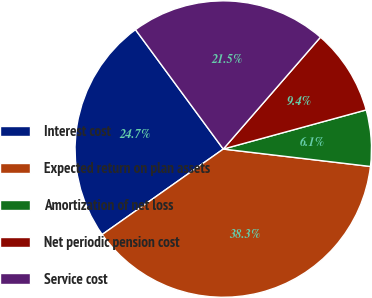Convert chart to OTSL. <chart><loc_0><loc_0><loc_500><loc_500><pie_chart><fcel>Interest cost<fcel>Expected return on plan assets<fcel>Amortization of net loss<fcel>Net periodic pension cost<fcel>Service cost<nl><fcel>24.69%<fcel>38.34%<fcel>6.13%<fcel>9.36%<fcel>21.47%<nl></chart> 